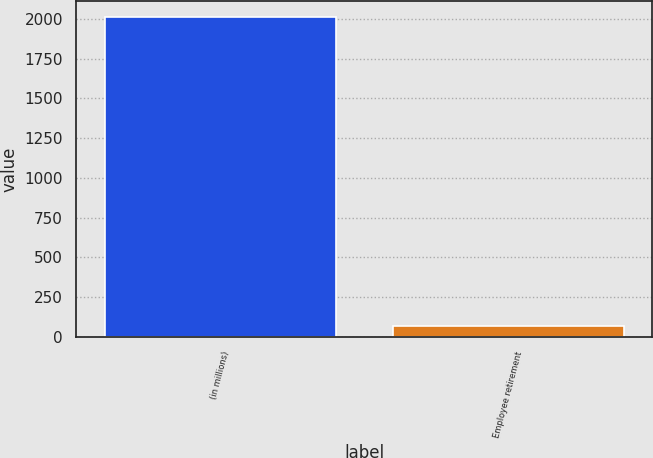<chart> <loc_0><loc_0><loc_500><loc_500><bar_chart><fcel>(in millions)<fcel>Employee retirement<nl><fcel>2011<fcel>69.9<nl></chart> 